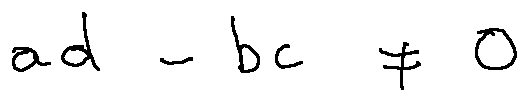<formula> <loc_0><loc_0><loc_500><loc_500>a d - b c \neq 0</formula> 